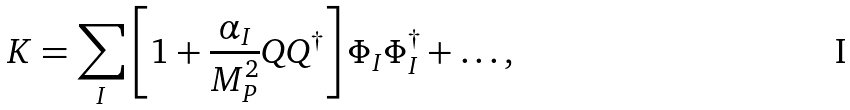<formula> <loc_0><loc_0><loc_500><loc_500>K = \sum _ { I } \left [ 1 + \frac { \alpha _ { I } } { M _ { P } ^ { 2 } } Q Q ^ { \dagger } \right ] \Phi _ { I } \Phi ^ { \dagger } _ { I } + \dots ,</formula> 